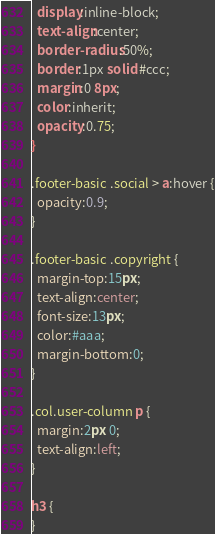Convert code to text. <code><loc_0><loc_0><loc_500><loc_500><_CSS_>  display:inline-block;
  text-align:center;
  border-radius:50%;
  border:1px solid #ccc;
  margin:0 8px;
  color:inherit;
  opacity:0.75;
}

.footer-basic .social > a:hover {
  opacity:0.9;
}

.footer-basic .copyright {
  margin-top:15px;
  text-align:center;
  font-size:13px;
  color:#aaa;
  margin-bottom:0;
}

.col.user-column p {
  margin:2px 0;
  text-align:left;
}

h3 {
}

</code> 